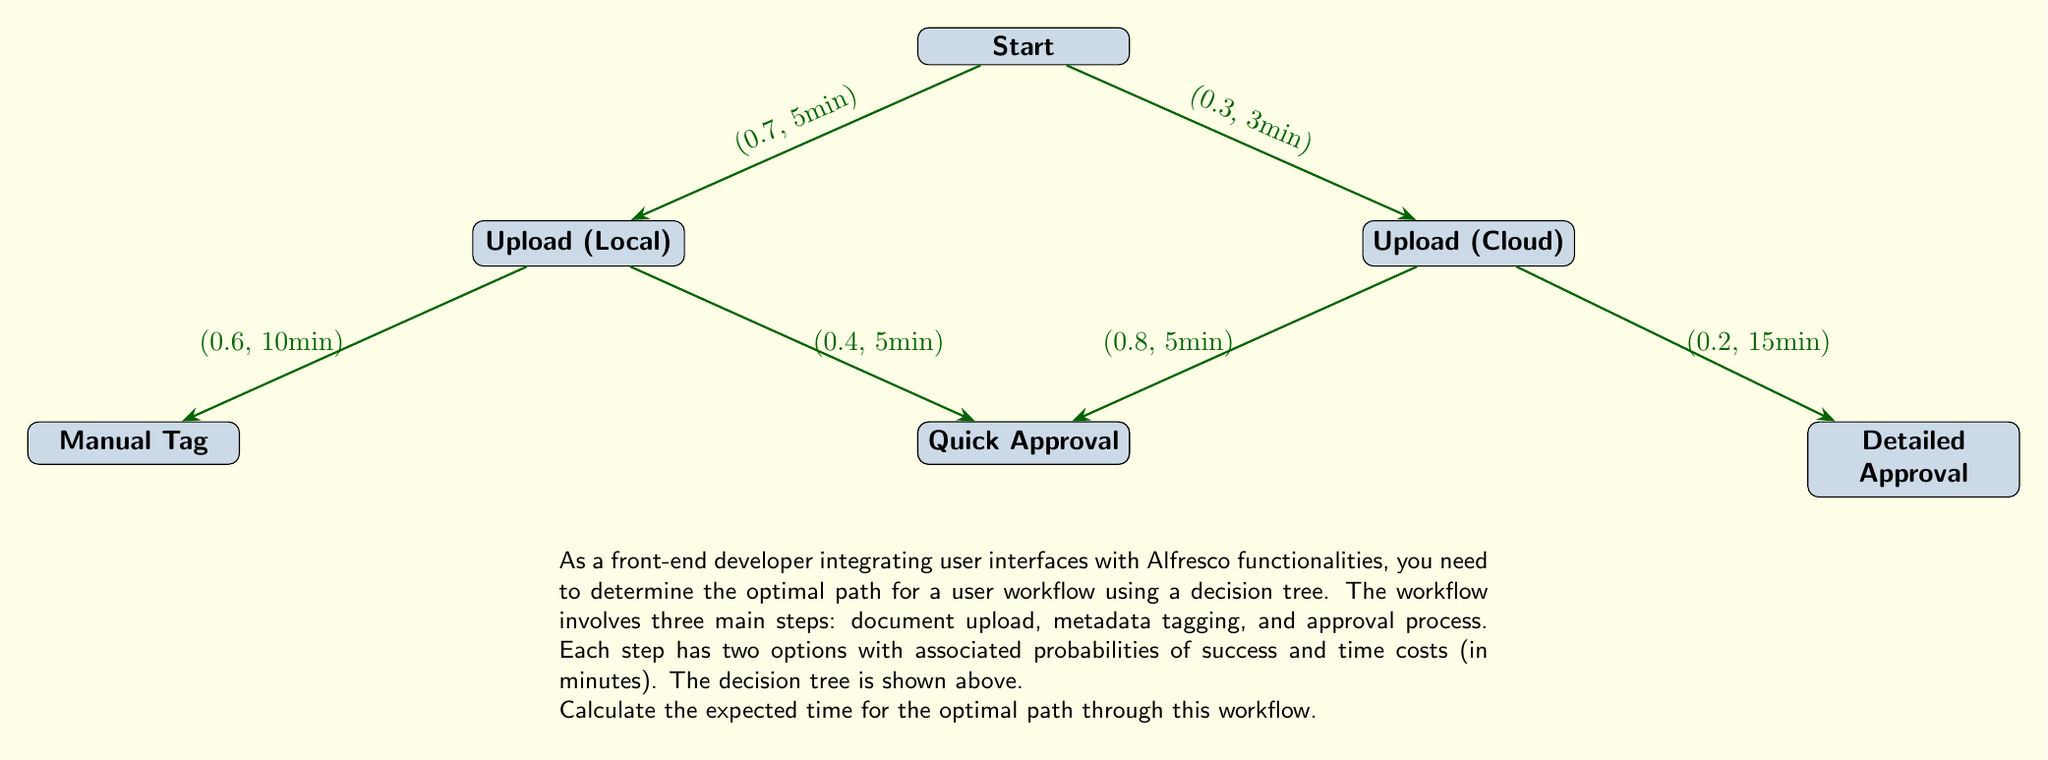Can you solve this math problem? To determine the optimal path, we need to calculate the expected time for each possible path and choose the one with the lowest expected time. We'll work backwards from the end of the tree to the start.

Step 1: Calculate expected times for the upload options

1. Local Upload:
   $$E(\text{Local}) = 5 + (0.6 \times 10 + 0.4 \times 5) = 5 + 8 = 13\text{ minutes}$$

2. Cloud Upload:
   $$E(\text{Cloud}) = 3 + (0.8 \times 5 + 0.2 \times 15) = 3 + 7 = 10\text{ minutes}$$

Step 2: Compare the two upload options
Cloud Upload has a lower expected time (10 minutes) compared to Local Upload (13 minutes), so we choose Cloud Upload as the optimal first step.

Step 3: Calculate the overall expected time for the optimal path
$$E(\text{Optimal}) = 0.3 \times 10 = 3\text{ minutes}$$

Therefore, the expected time for the optimal path through this workflow is 3 minutes.
Answer: 3 minutes 